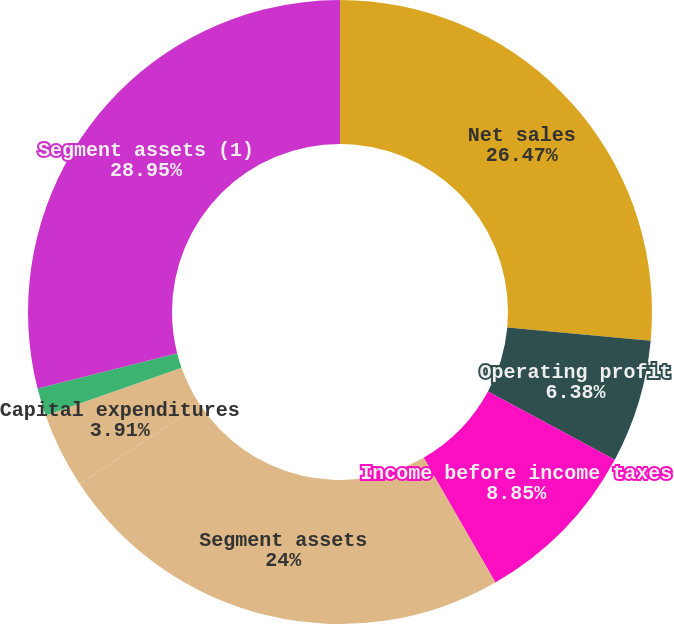<chart> <loc_0><loc_0><loc_500><loc_500><pie_chart><fcel>Net sales<fcel>Operating profit<fcel>Income before income taxes<fcel>Segment assets<fcel>Capital expenditures<fcel>Depreciation and amortization<fcel>Segment assets (1)<nl><fcel>26.47%<fcel>6.38%<fcel>8.85%<fcel>24.0%<fcel>3.91%<fcel>1.44%<fcel>28.94%<nl></chart> 